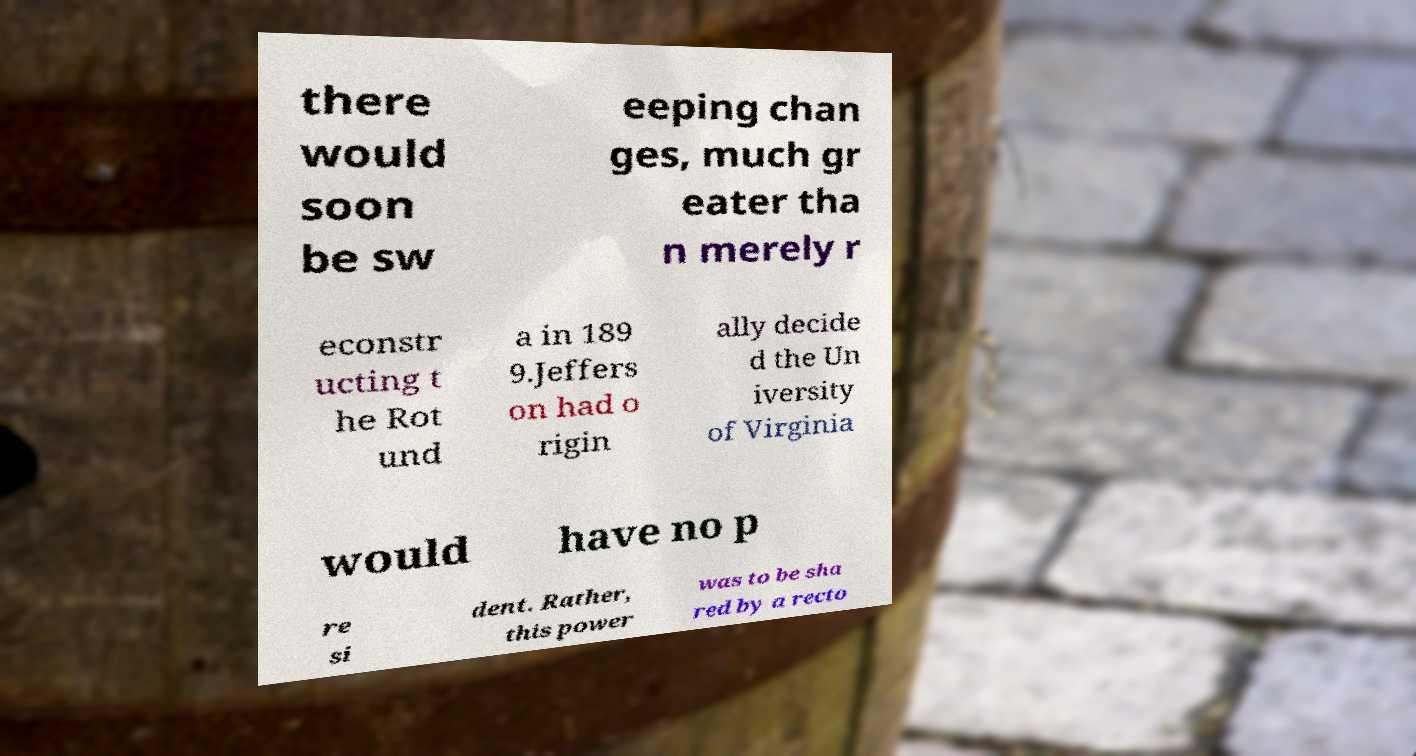Please read and relay the text visible in this image. What does it say? there would soon be sw eeping chan ges, much gr eater tha n merely r econstr ucting t he Rot und a in 189 9.Jeffers on had o rigin ally decide d the Un iversity of Virginia would have no p re si dent. Rather, this power was to be sha red by a recto 